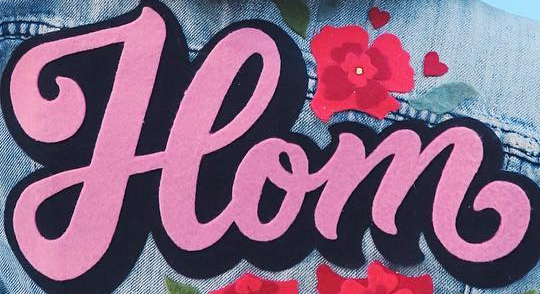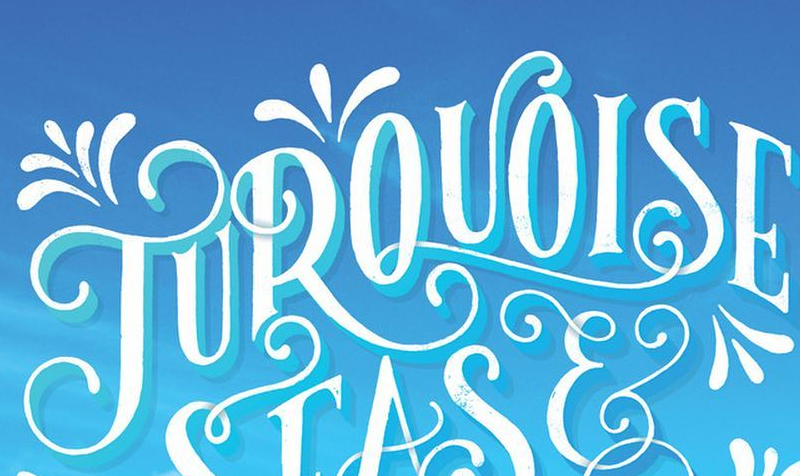What text is displayed in these images sequentially, separated by a semicolon? Hom; TUROUOISE 